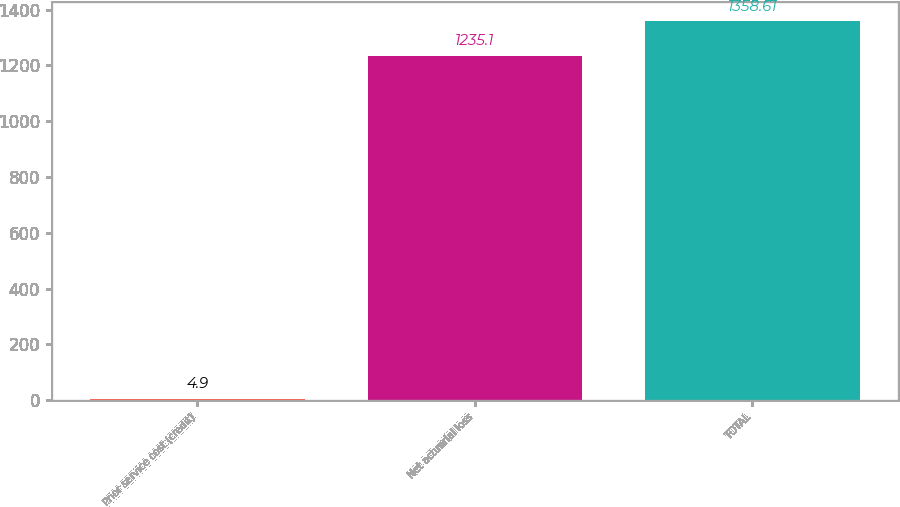Convert chart. <chart><loc_0><loc_0><loc_500><loc_500><bar_chart><fcel>Prior service cost (credit)<fcel>Net actuarial loss<fcel>TOTAL<nl><fcel>4.9<fcel>1235.1<fcel>1358.61<nl></chart> 